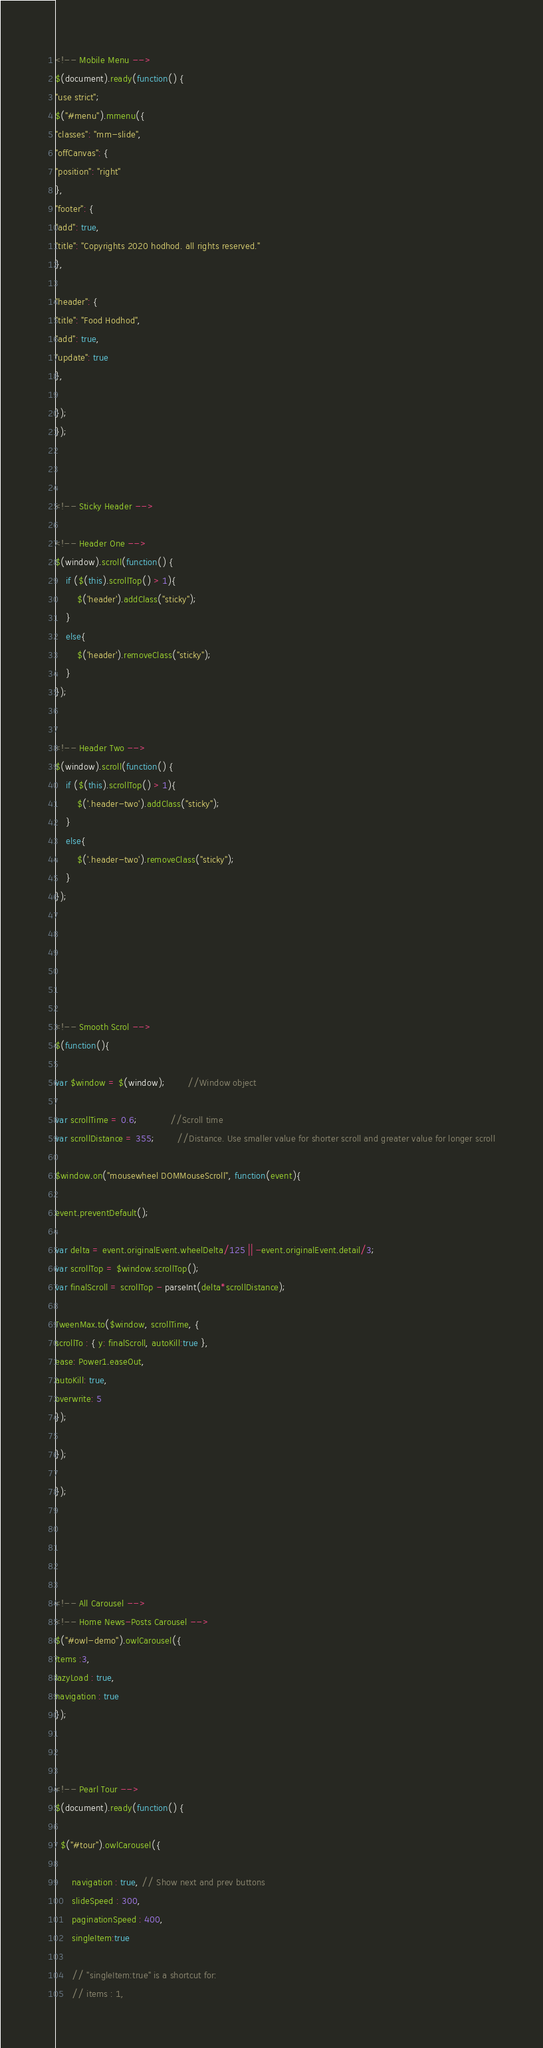Convert code to text. <code><loc_0><loc_0><loc_500><loc_500><_JavaScript_>
<!-- Mobile Menu -->
$(document).ready(function() {
"use strict";
$("#menu").mmenu({
"classes": "mm-slide",
"offCanvas": {
"position": "right"
},
"footer": {
"add": true,
"title": "Copyrights 2020 hodhod. all rights reserved."
},

"header": {
"title": "Food Hodhod",
"add": true,
"update": true
},

});
});



<!-- Sticky Header -->

<!-- Header One -->
$(window).scroll(function() {
    if ($(this).scrollTop() > 1){
        $('header').addClass("sticky");
    }
    else{
        $('header').removeClass("sticky");
    }
});


<!-- Header Two -->
$(window).scroll(function() {
    if ($(this).scrollTop() > 1){
        $('.header-two').addClass("sticky");
    }
    else{
        $('.header-two').removeClass("sticky");
    }
});






<!-- Smooth Scrol -->
$(function(){

var $window = $(window);		//Window object

var scrollTime = 0.6;			//Scroll time
var scrollDistance = 355;		//Distance. Use smaller value for shorter scroll and greater value for longer scroll

$window.on("mousewheel DOMMouseScroll", function(event){

event.preventDefault();

var delta = event.originalEvent.wheelDelta/125 || -event.originalEvent.detail/3;
var scrollTop = $window.scrollTop();
var finalScroll = scrollTop - parseInt(delta*scrollDistance);

TweenMax.to($window, scrollTime, {
scrollTo : { y: finalScroll, autoKill:true },
ease: Power1.easeOut,
autoKill: true,
overwrite: 5
});

});

});





<!-- All Carousel -->
<!-- Home News-Posts Carousel -->
$("#owl-demo").owlCarousel({
items :3,
lazyLoad : true,
navigation : true
});



<!-- Pearl Tour -->
$(document).ready(function() {

  $("#tour").owlCarousel({

      navigation : true, // Show next and prev buttons
      slideSpeed : 300,
      paginationSpeed : 400,
      singleItem:true

      // "singleItem:true" is a shortcut for:
      // items : 1,</code> 